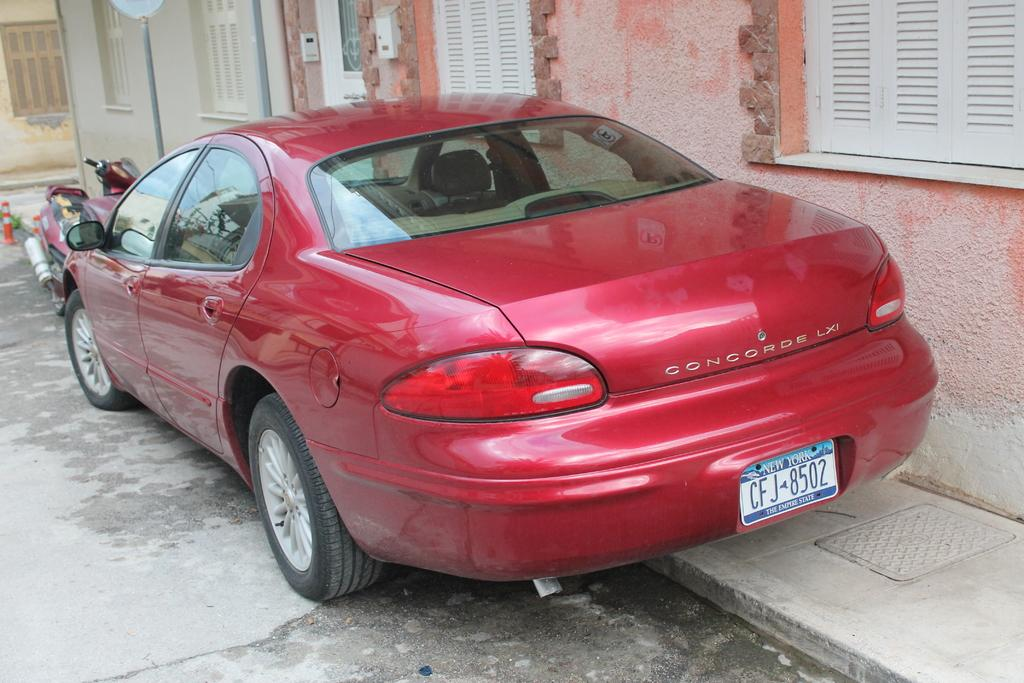<image>
Describe the image concisely. A red car with the word Concorde on the back of fit. 